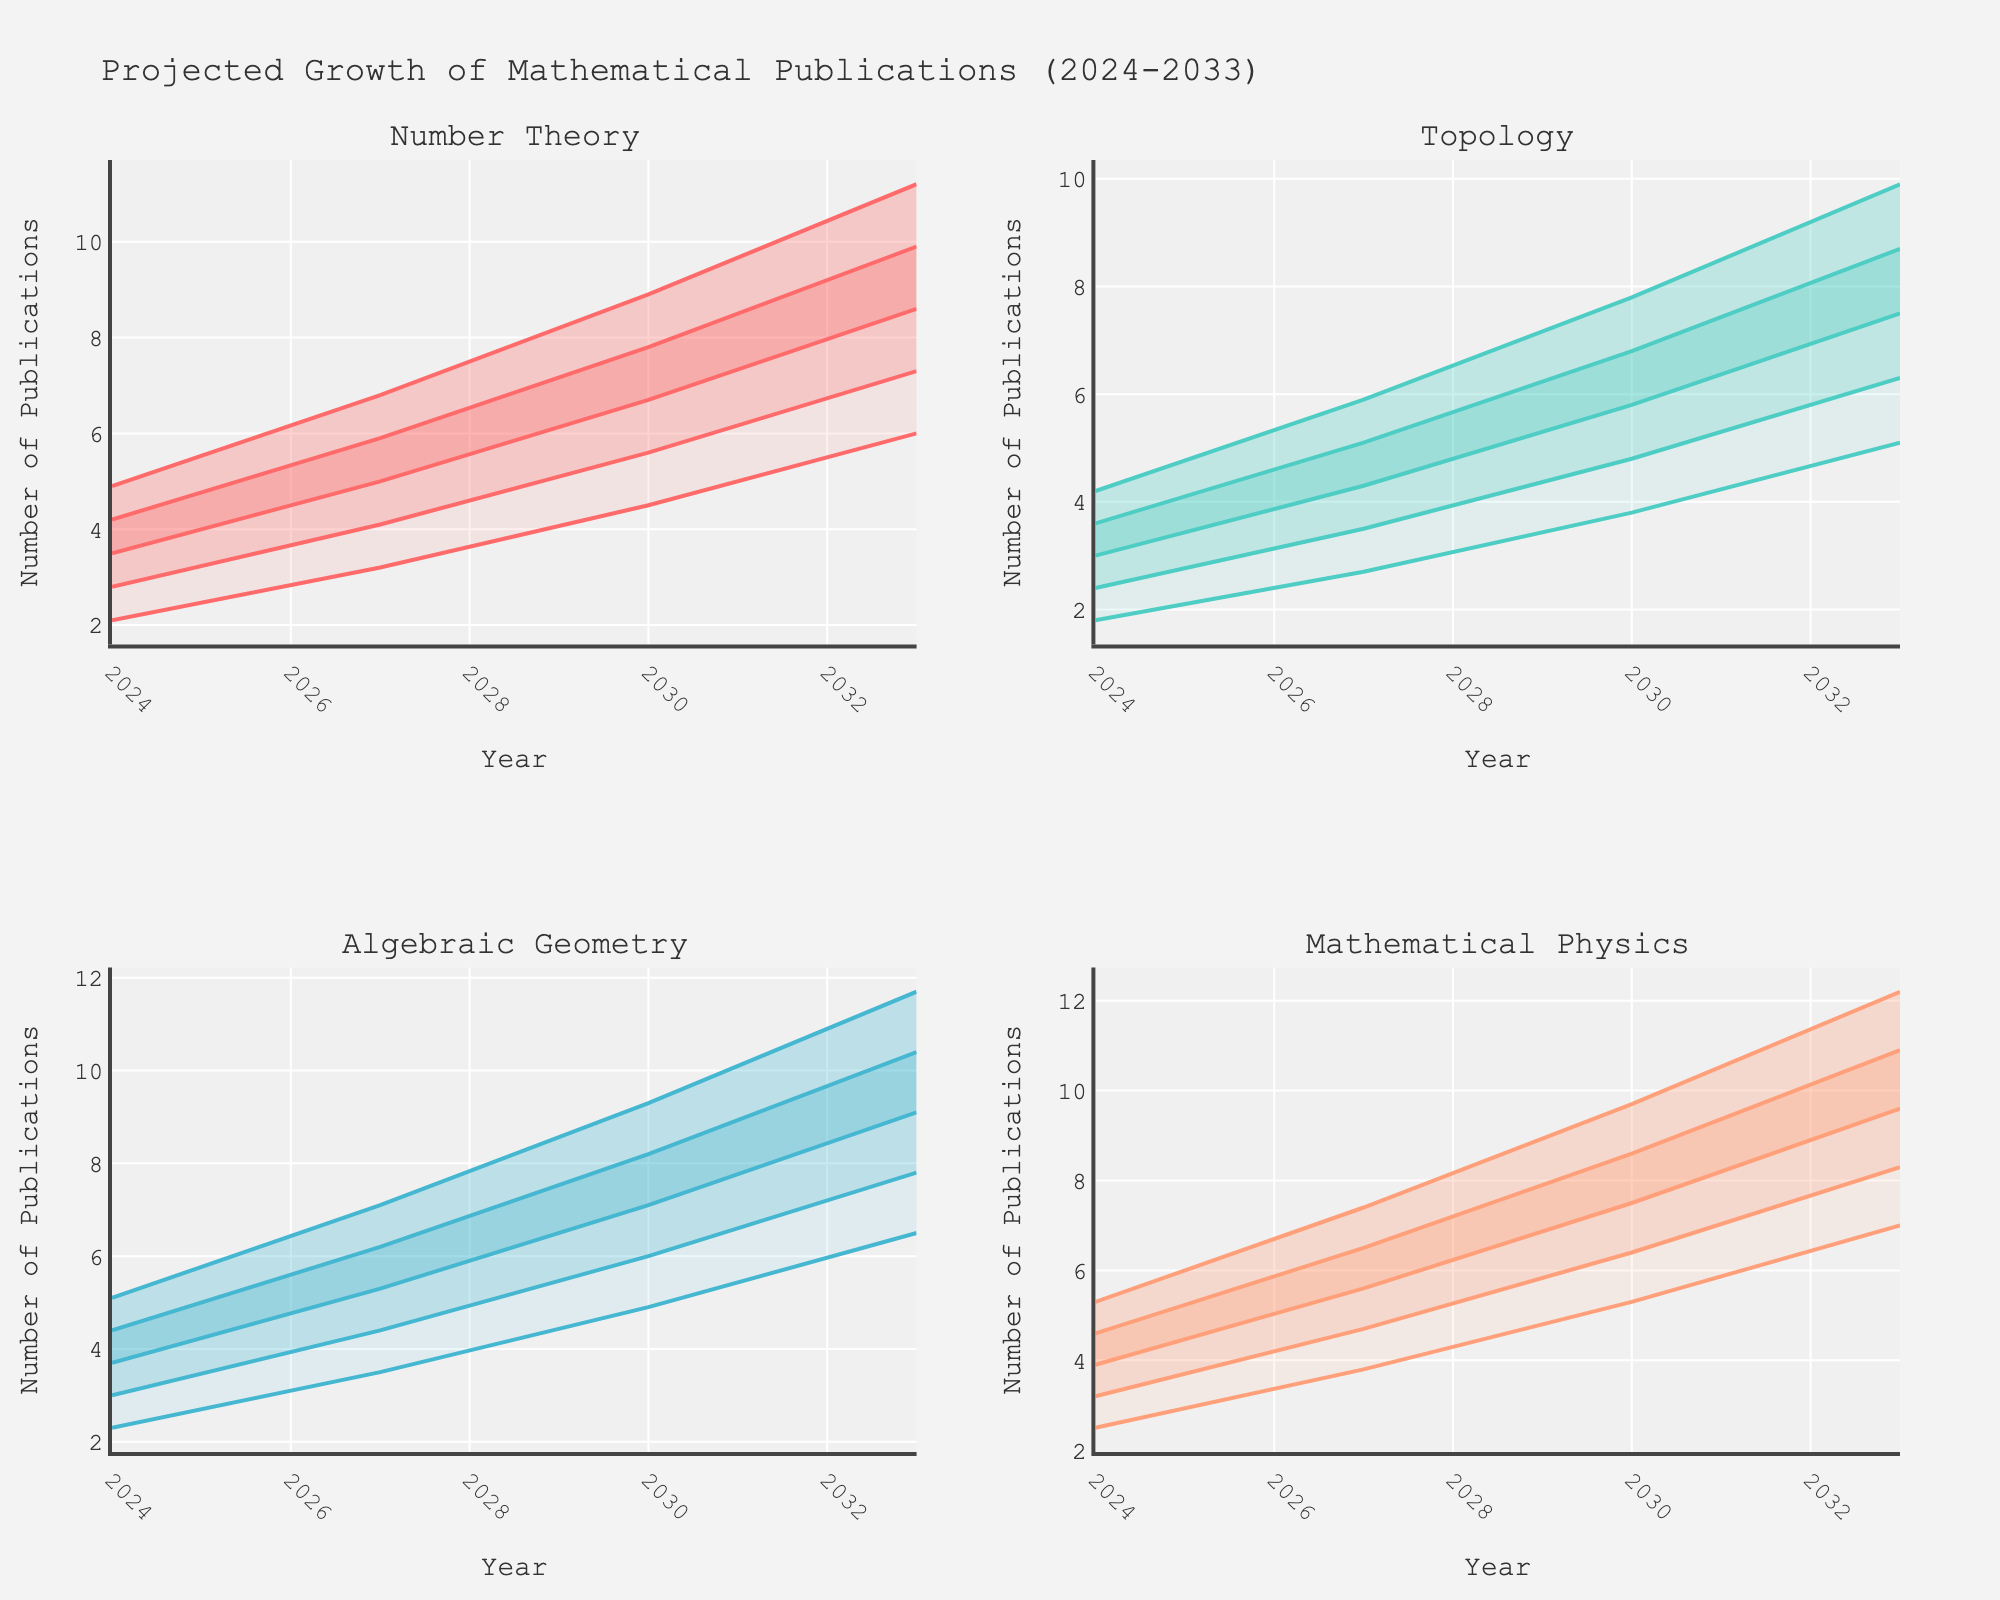what is the title of the figure? The title of the figure is located at the top and is usually presented in a larger, bold font
Answer: Projected Growth of Mathematical Publications (2024-2033) How many subfields are represented in the figure? The subplot titles identify each distinct subfield. There are four subplot titles.
Answer: 4 Which subfield has the highest median number of publications projected for the year 2033? To find the highest median number in 2033, locate where 2033 aligns in each subfield and identify the subplot with the highest median value.
Answer: Mathematical Physics In 2027, what is the difference between the median number of publications in Number Theory and Topology? Locate the median values for both subfields in 2027 and subtract the smaller value from the larger one to find the difference. Number Theory's median is 5.0, and Topology's median is 4.3.
Answer: 0.7 Which subfield shows the greatest increase in the median number of publications from 2024 to 2033? Calculate the median increase for each subfield by subtracting the 2024 median value from the 2033 median value. Algebraic Geometry increases from 3.7 to 9.1, the highest increase among the subfields.
Answer: Algebraic Geometry How does the uncertainty range (difference between upper and lower values) for Topology in 2024 compare to that in 2033? Calculate the uncertainty range for both years: subtract the lower value from the upper value. For 2024, it is 4.2 - 1.8 = 2.4, and for 2033, it is 9.9 - 5.1 = 4.8.
Answer: Greater in 2033 Which subfield has the smallest uncertainty range in 2024? Calculate the uncertainty range (Upper - Lower) for each subfield in 2024 and compare. Topology's range from 1.8 to 4.2 is the smallest, 4.2 - 1.8 = 2.4.
Answer: Topology By how much is the median number of Algebraic Geometry publications projected to grow from 2027 to 2030? Find the difference between the projected median values for 2027 (5.3) and 2030 (7.1).
Answer: 1.8 In 2027, which subfield has the narrowest uncertainty range? Calculate and compare the uncertainty ranges for all subfields in 2027. Topology, with a range from 2.7 to 5.9 (5.9 - 2.7 = 3.2), is the narrowest.
Answer: Topology What is the general trend of mathematical publication numbers across all subfields over the next decade? Observe the patterns of the median values across all subfields for each year from 2024 to 2033. All subfields show an increasing trend in the median number of publications.
Answer: Increasing 